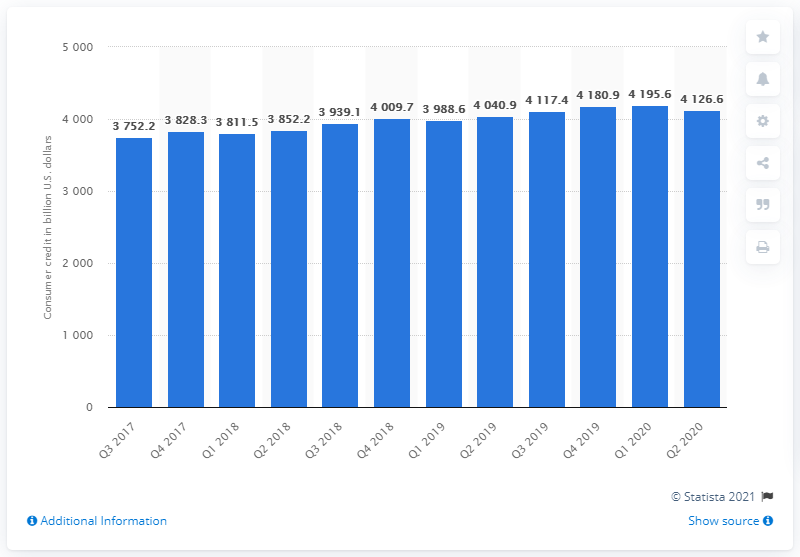Highlight a few significant elements in this photo. In the second quarter of 2020, the outstanding amount of consumer credit in the United States was approximately 41,266.6. 